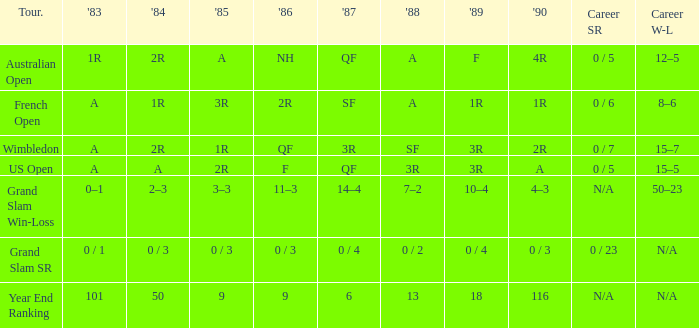In 1983, which event features a 0/1 outcome? Grand Slam SR. 